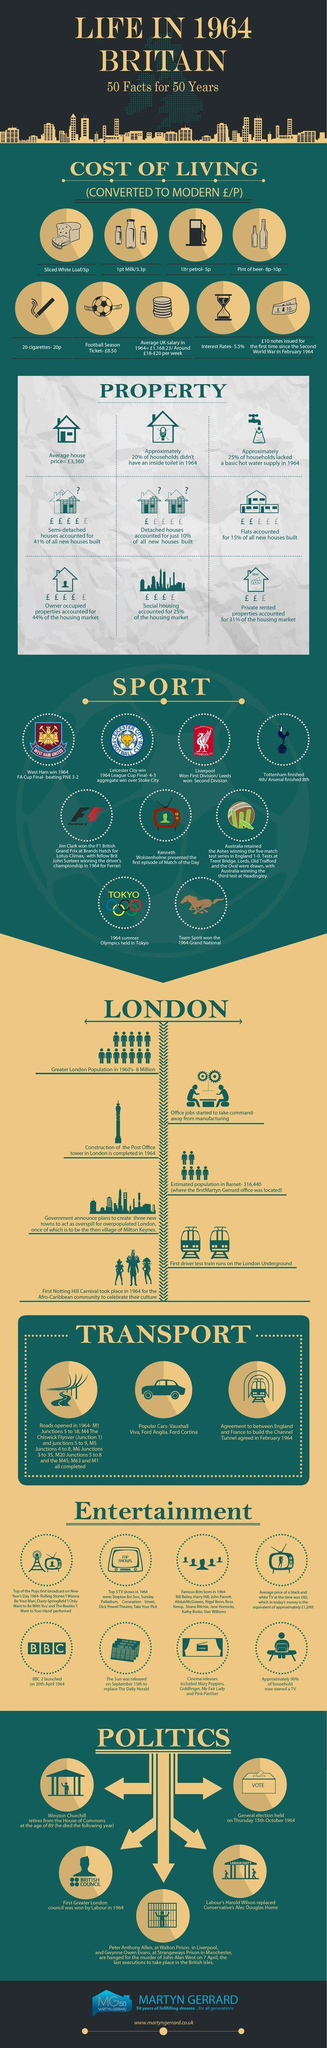What is the average house price in Britain in 1964?
Answer the question with a short phrase. €3360 Which football club won the FA Cup in the year 1964? West Ham When was BBC 2 launched? 20th April 1964 At what age did Winston Churchill retired form The House of Commons? 89 Construction of the Post Office Tower in London was completed in which year? 1964 When was the general elections held? Thursday 15th October 1964 